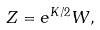<formula> <loc_0><loc_0><loc_500><loc_500>Z = e ^ { K / 2 } W ,</formula> 